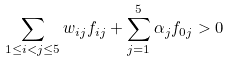<formula> <loc_0><loc_0><loc_500><loc_500>\sum _ { 1 \leq i < j \leq 5 } w _ { i j } f _ { i j } + \sum _ { j = 1 } ^ { 5 } \alpha _ { j } f _ { 0 j } > 0</formula> 